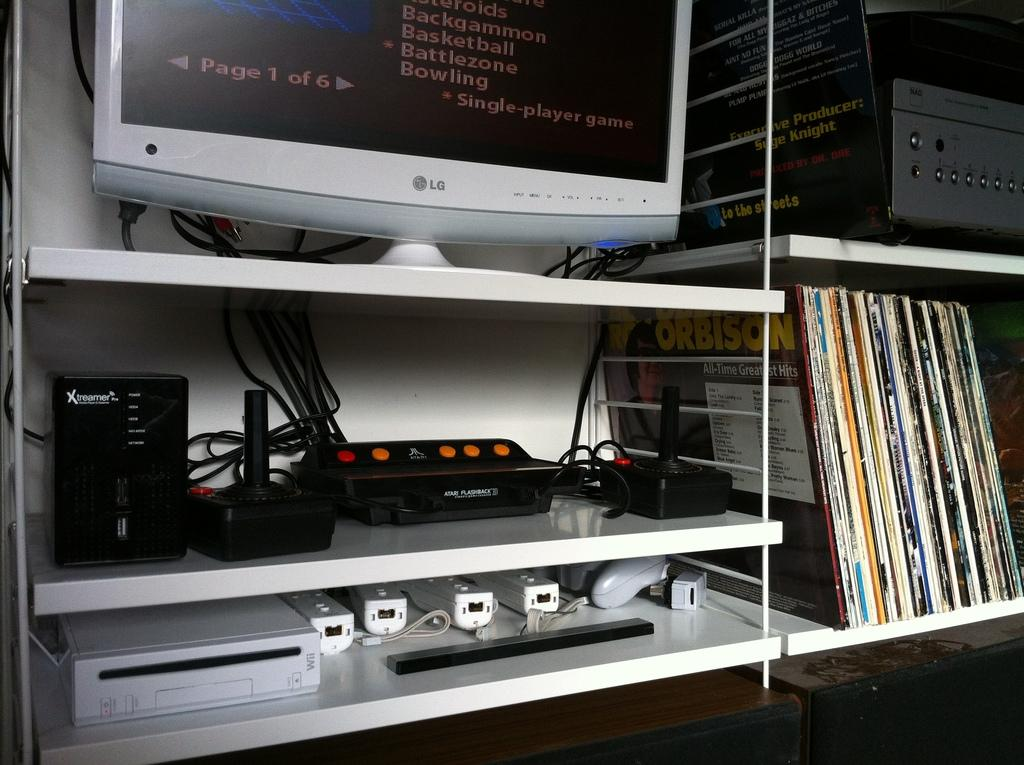<image>
Render a clear and concise summary of the photo. a LG screen is open to  page 1 of 6 and the shelves are full of things as well 